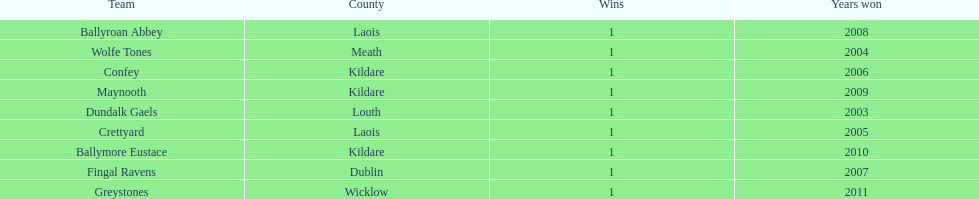Which team won previous to crettyard? Wolfe Tones. 